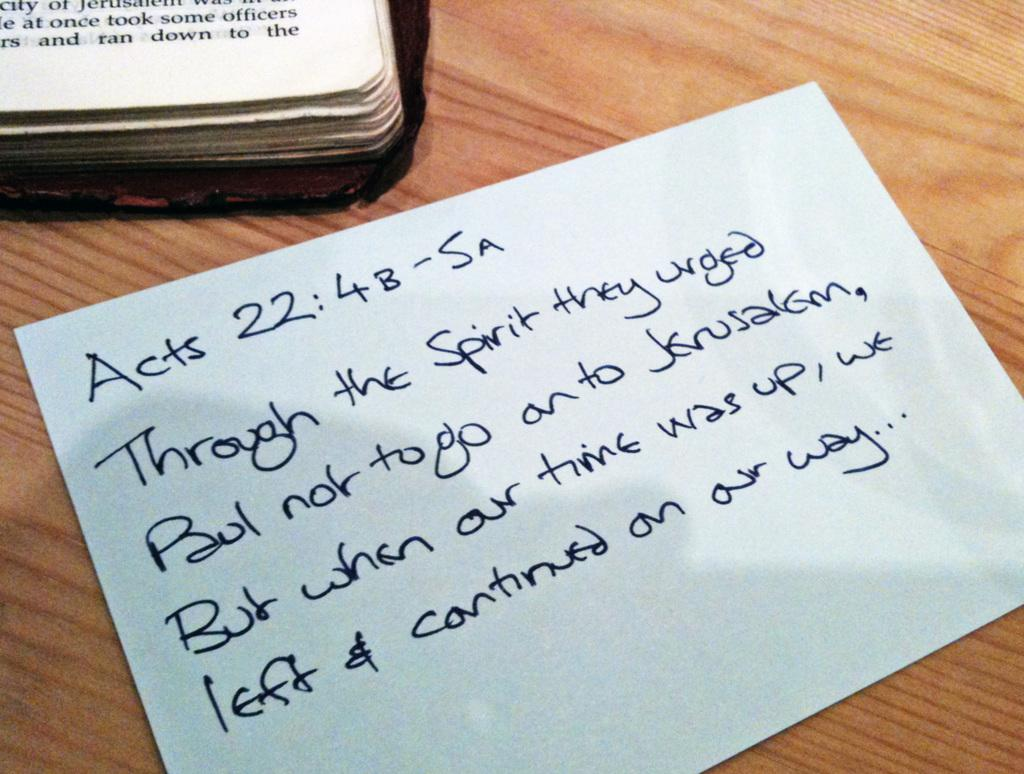<image>
Create a compact narrative representing the image presented. the word acts is on a piece of paper 